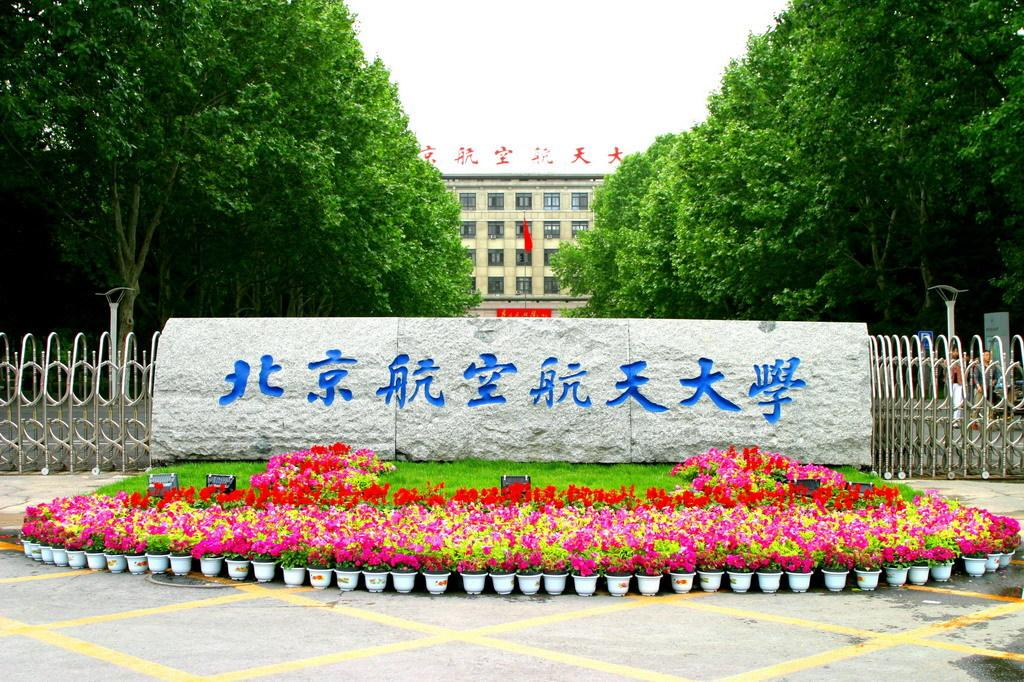What type of structure can be seen in the image? There is a fence in the image. What type of plants are visible in the image? There are flowers in the image. What can be seen in the background of the image? There are trees, a building, and the sky visible in the background of the image. Where is the shelf located in the image? There is no shelf present in the image. What type of can is visible in the image? There is no can present in the image. 